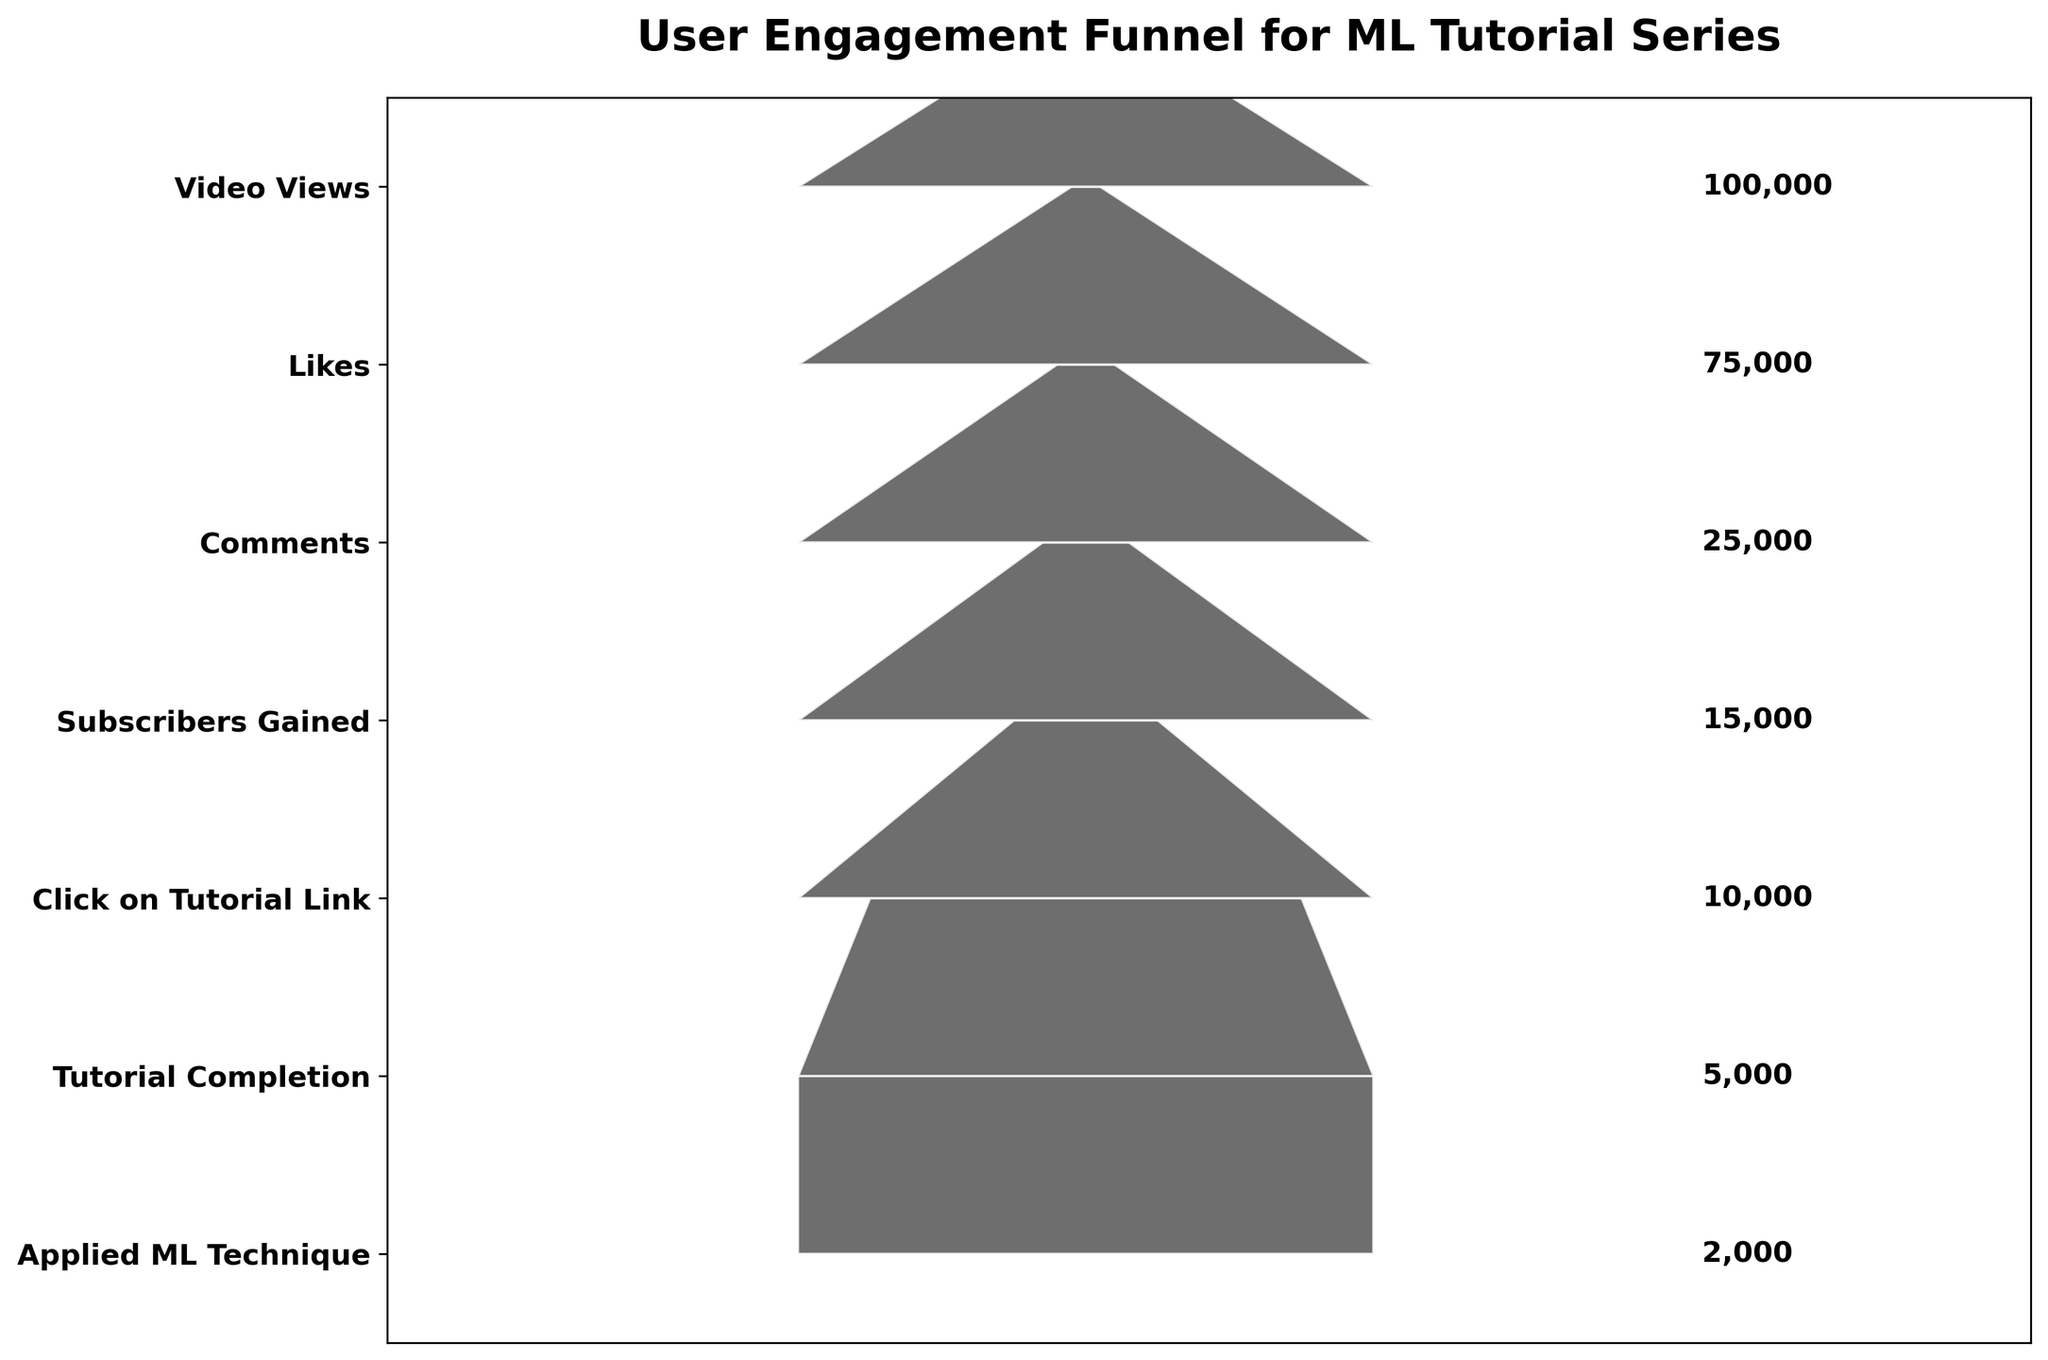What is the title of the funnel chart? The title is clearly displayed at the top of the funnel chart.
Answer: User Engagement Funnel for ML Tutorial Series How many steps are there in the funnel chart? By counting the labeled steps on the chart's y-axis, we can determine the number of steps.
Answer: 7 Which step has the highest number of users? By looking at the width of the segments, the top segment is the widest, indicating the highest number of users.
Answer: Video Views How many users clicked on the tutorial link? The number of users who clicked on the tutorial link is labeled on the right side of the corresponding segment.
Answer: 10,000 What is the percentage decrease in users from 'Likes' to 'Comments'? To find the percentage decrease, first determine the difference between the two steps, then divide the difference by the initial value (Likes), and multiply by 100. Calculation: (75,000 - 25,000) / 75,000 * 100 = 66.67%.
Answer: 66.67% How does the number of 'Tutorial Completion' compare to 'Subscribers Gained'? Compare the numbers labeled on the right side of the corresponding segments: Tutorial Completion (5,000) and Subscribers Gained (15,000).
Answer: Tutorial Completion has fewer users than Subscribers Gained What is the drop-off rate from 'Video Views' to 'Likes'? Calculate the difference and divide by the initial number (Video Views): (100,000 - 75,000) / 100,000 * 100 = 25%.
Answer: 25% Which step shows the greatest drop in user numbers? By observing the difference in widths between consecutive segments, the largest drop is seen between 'Likes' (75,000) and 'Comments' (25,000).
Answer: Likes to Comments How many users applied the ML technique? The number of users who applied the ML technique is labeled on the right side of the corresponding segment.
Answer: 2,000 What is the relative size difference between 'Tutorial Completion' and 'Applied ML Technique'? Compare the user numbers for each step: Tutorial Completion (5,000) and Applied ML Technique (2,000). Calculate the ratio: 2000 / 5000 = 0.4 or 40%.
Answer: Applied ML Technique is 40% of Tutorial Completion 